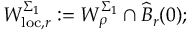Convert formula to latex. <formula><loc_0><loc_0><loc_500><loc_500>W _ { l o c , r } ^ { \Sigma _ { 1 } } \colon = W _ { \rho } ^ { \Sigma _ { 1 } } \cap \widehat { B } _ { r } ( 0 ) ;</formula> 